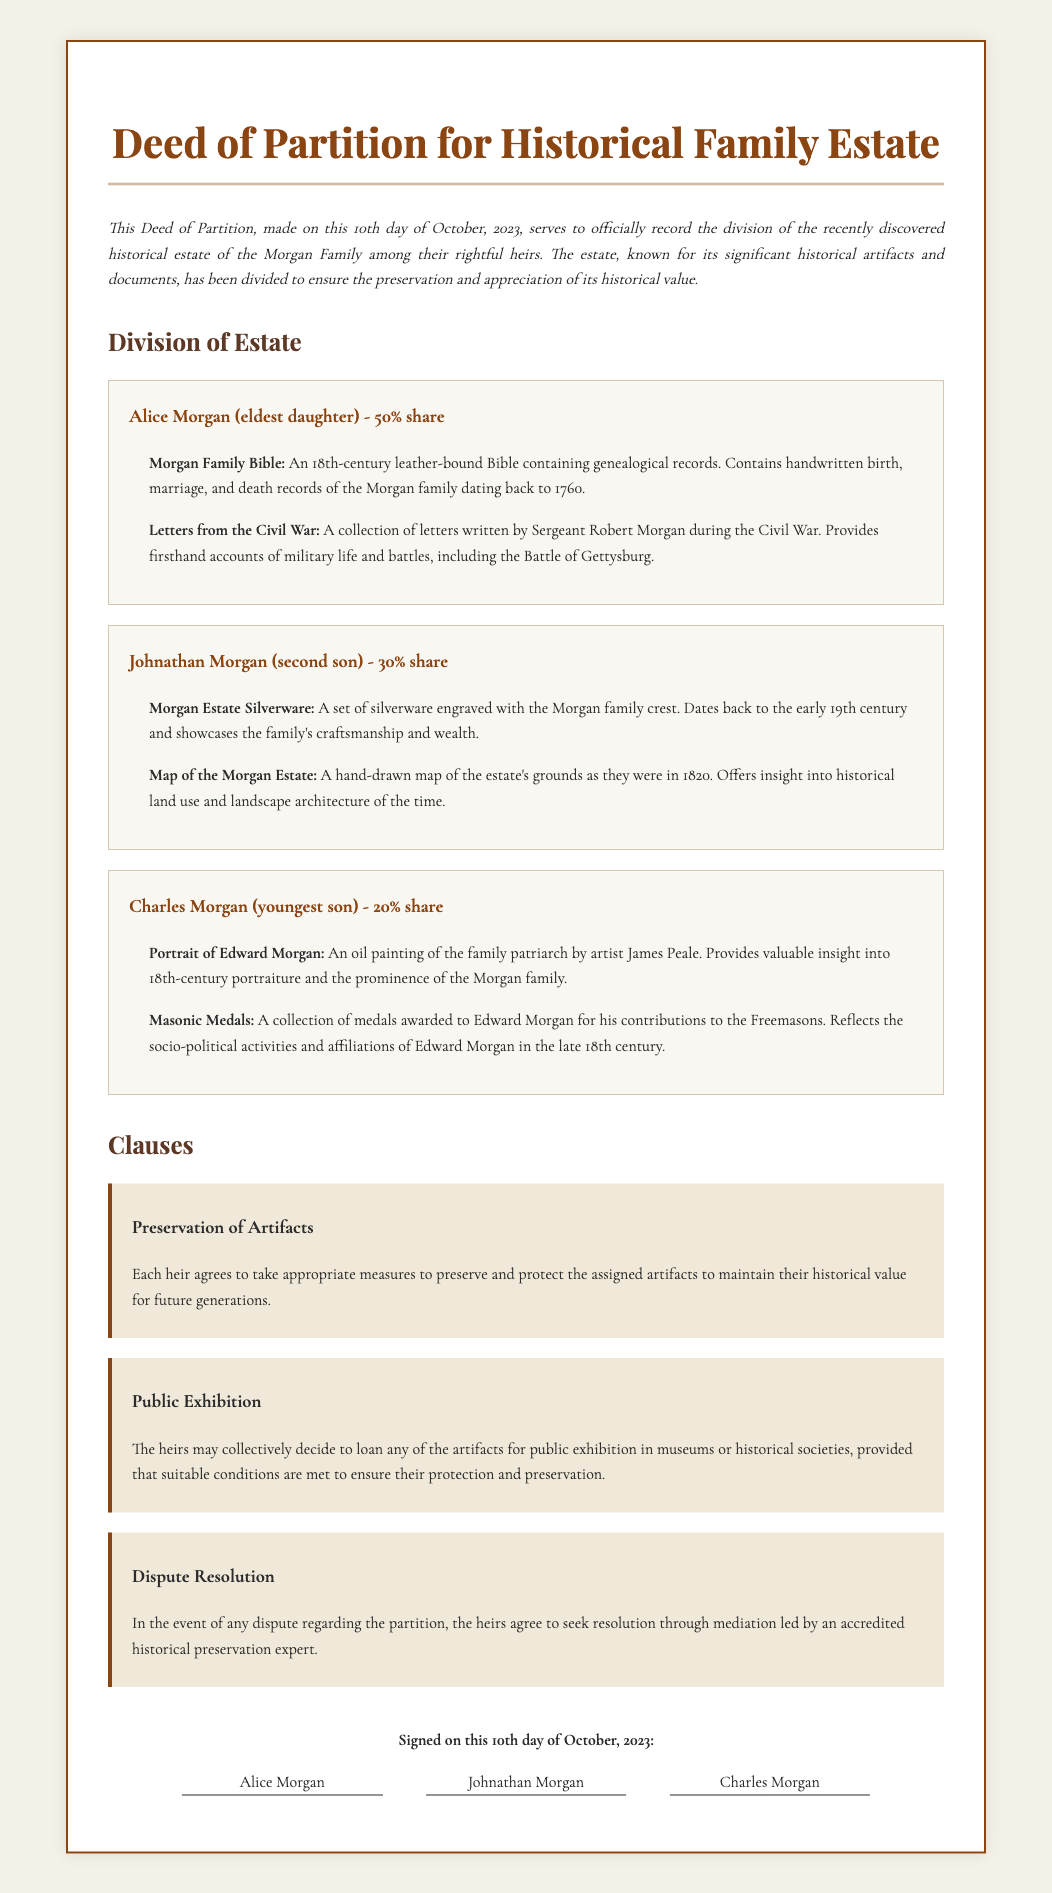What date was the Deed of Partition made? The document states that the Deed of Partition was made on the 10th day of October, 2023.
Answer: 10th day of October, 2023 Who is the eldest daughter of the Morgan Family? The document identifies Alice Morgan as the eldest daughter receiving a 50% share of the estate.
Answer: Alice Morgan What percentage share does Johnathan Morgan receive? According to the document, Johnathan Morgan is assigned a 30% share of the estate.
Answer: 30% What historical item is linked to the Civil War? The document mentions a collection of letters written by Sergeant Robert Morgan during the Civil War as a relevant artifact.
Answer: Letters from the Civil War What does the clause about Preservation of Artifacts require? The Preservation of Artifacts clause specifies that each heir must take measures to preserve and protect the assigned artifacts.
Answer: To preserve and protect How many artifacts are listed under Charles Morgan? The document lists two artifacts under Charles Morgan, specifically a portrait and a set of medals.
Answer: Two What is required for public exhibition of artifacts? The heirs must collectively decide on the loan of artifacts for public exhibition, ensuring protection and preservation.
Answer: Collective decision Which historical figure's portrait is mentioned? The document references a portrait of Edward Morgan painted by artist James Peale.
Answer: Edward Morgan What is the purpose of the Dispute Resolution clause? The Dispute Resolution clause requires heirs to seek mediation led by a historical preservation expert in the event of a dispute.
Answer: Mediation by expert 